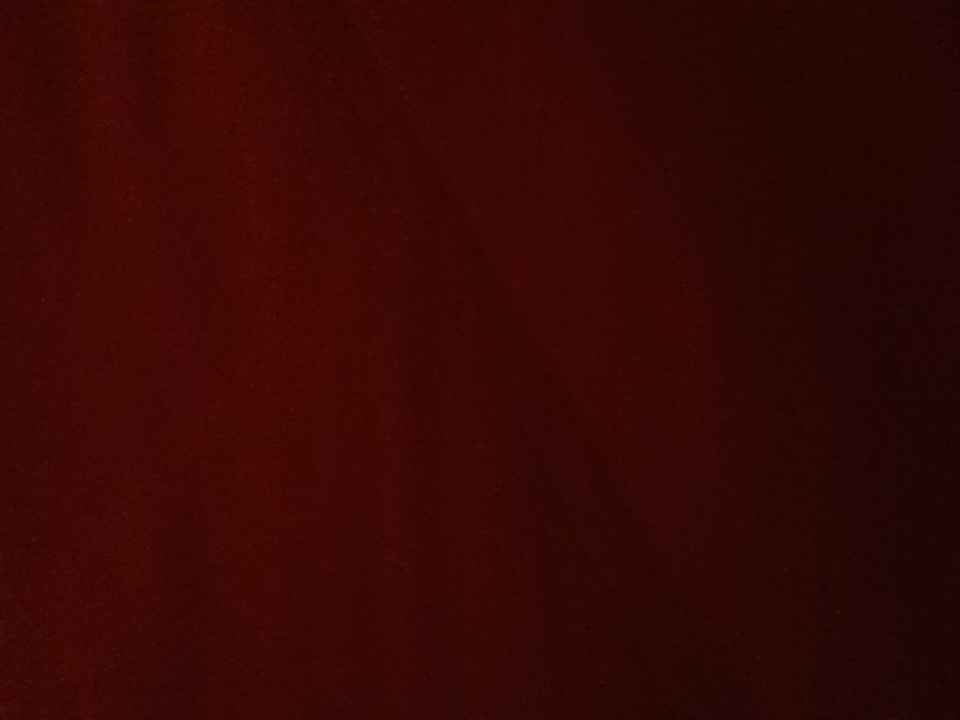Imagine this is the backdrop of a magical world. What kind of creatures and landscapes might you find here? In a magical world with this deep red backdrop, you might encounter ethereal creatures like crimson phoenixes, whose feathers shimmer with fiery brilliance. The landscape could be dotted with ruby-encrusted mountains, glowing in the twilight, and forests where trees have leaves of deep garnet, whispering ancient spells with every breeze. Rivers of shimmering scarlet water might flow through this land, teeming with life and secrets waiting to be uncovered. What kind of adventures might take place in such a world? Adventures in this magical world would be epic and filled with awe-inspiring quests. Heroes might embark on a journey to seek the legendary Crimson Elixir, said to grant immortality, guarded by the enigmatic and majestic phoenixes. Along the way, they would traverse ruby-studded caverns, solve ancient riddles from the whispering trees, and brave the currents of the scarlet rivers to uncover the power lying within. Allies and foes alike, from mystical forest spirits to towering, gem-covered giants, would add to the rich tapestry of their odyssey. 